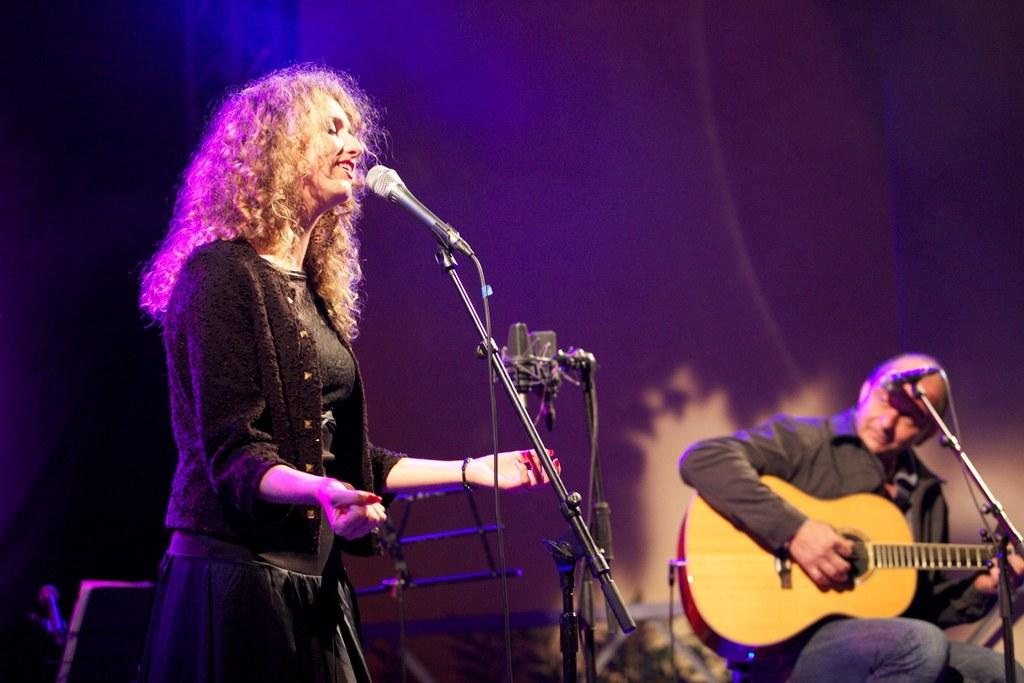Who is the main subject in the image? There is a woman in the image. What is the woman doing in the image? The woman is standing in front of a mic. Are there any other people in the image? Yes, there is a man in the image. What is the man doing in the image? The man is sitting and holding a guitar in his hands. Is the man also in front of a mic? Yes, the man is also in front of a mic. What type of pollution can be seen in the image? There is no pollution visible in the image; it features a woman standing in front of a mic and a man sitting with a guitar. 